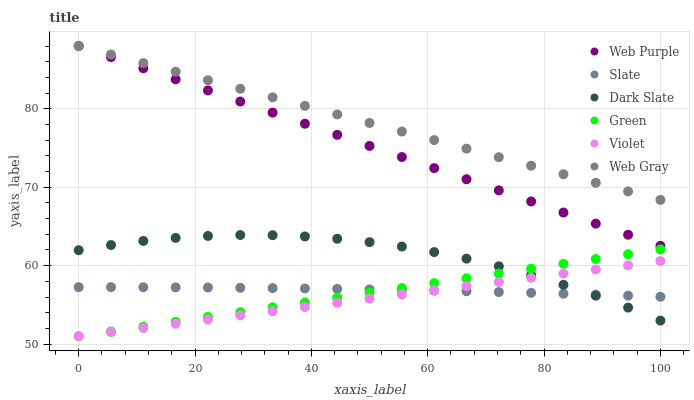Does Violet have the minimum area under the curve?
Answer yes or no. Yes. Does Web Gray have the maximum area under the curve?
Answer yes or no. Yes. Does Slate have the minimum area under the curve?
Answer yes or no. No. Does Slate have the maximum area under the curve?
Answer yes or no. No. Is Green the smoothest?
Answer yes or no. Yes. Is Dark Slate the roughest?
Answer yes or no. Yes. Is Slate the smoothest?
Answer yes or no. No. Is Slate the roughest?
Answer yes or no. No. Does Green have the lowest value?
Answer yes or no. Yes. Does Slate have the lowest value?
Answer yes or no. No. Does Web Purple have the highest value?
Answer yes or no. Yes. Does Dark Slate have the highest value?
Answer yes or no. No. Is Violet less than Web Purple?
Answer yes or no. Yes. Is Web Gray greater than Green?
Answer yes or no. Yes. Does Green intersect Dark Slate?
Answer yes or no. Yes. Is Green less than Dark Slate?
Answer yes or no. No. Is Green greater than Dark Slate?
Answer yes or no. No. Does Violet intersect Web Purple?
Answer yes or no. No. 